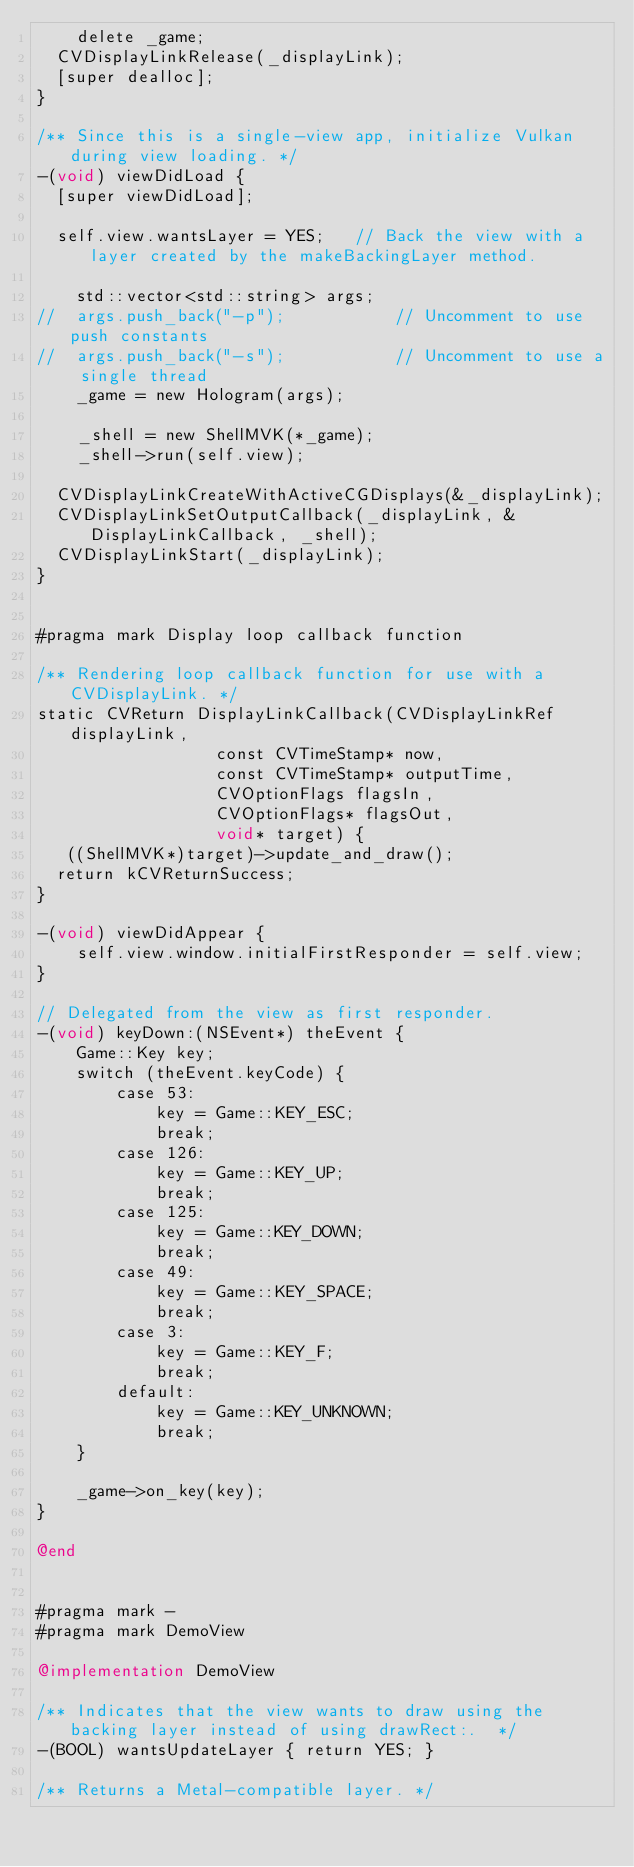Convert code to text. <code><loc_0><loc_0><loc_500><loc_500><_ObjectiveC_>    delete _game;
	CVDisplayLinkRelease(_displayLink);
	[super dealloc];
}

/** Since this is a single-view app, initialize Vulkan during view loading. */
-(void) viewDidLoad {
	[super viewDidLoad];

	self.view.wantsLayer = YES;		// Back the view with a layer created by the makeBackingLayer method.

    std::vector<std::string> args;
//  args.push_back("-p");           // Uncomment to use push constants
//  args.push_back("-s");           // Uncomment to use a single thread
    _game = new Hologram(args);

    _shell = new ShellMVK(*_game);
    _shell->run(self.view);

	CVDisplayLinkCreateWithActiveCGDisplays(&_displayLink);
	CVDisplayLinkSetOutputCallback(_displayLink, &DisplayLinkCallback, _shell);
	CVDisplayLinkStart(_displayLink);
}


#pragma mark Display loop callback function

/** Rendering loop callback function for use with a CVDisplayLink. */
static CVReturn DisplayLinkCallback(CVDisplayLinkRef displayLink,
									const CVTimeStamp* now,
									const CVTimeStamp* outputTime,
									CVOptionFlags flagsIn,
									CVOptionFlags* flagsOut,
									void* target) {
   ((ShellMVK*)target)->update_and_draw();
	return kCVReturnSuccess;
}

-(void) viewDidAppear {
    self.view.window.initialFirstResponder = self.view;
}

// Delegated from the view as first responder.
-(void) keyDown:(NSEvent*) theEvent {
    Game::Key key;
    switch (theEvent.keyCode) {
        case 53:
            key = Game::KEY_ESC;
            break;
        case 126:
            key = Game::KEY_UP;
            break;
        case 125:
            key = Game::KEY_DOWN;
            break;
        case 49:
            key = Game::KEY_SPACE;
            break;
        case 3:
            key = Game::KEY_F;
            break;
        default:
            key = Game::KEY_UNKNOWN;
            break;
    }

    _game->on_key(key);
}

@end


#pragma mark -
#pragma mark DemoView

@implementation DemoView

/** Indicates that the view wants to draw using the backing layer instead of using drawRect:.  */
-(BOOL) wantsUpdateLayer { return YES; }

/** Returns a Metal-compatible layer. */</code> 